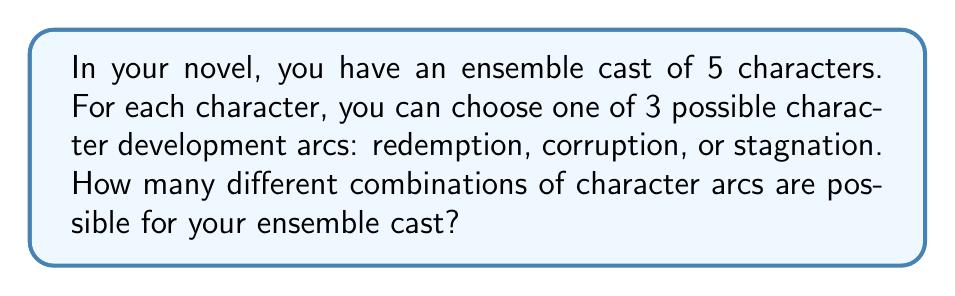Could you help me with this problem? Let's approach this step-by-step:

1) We have 5 characters, and for each character, we have 3 choices of character arcs.

2) This scenario is a perfect example of the multiplication principle in combinatorics. When we have a series of independent choices, we multiply the number of options for each choice.

3) In this case, we're making 5 independent choices (one for each character), and each choice has 3 options.

4) Therefore, the total number of possible combinations is:

   $$3 \times 3 \times 3 \times 3 \times 3 = 3^5$$

5) We can calculate this:

   $$3^5 = 3 \times 3 \times 3 \times 3 \times 3 = 243$$

6) This means there are 243 different ways to assign character arcs to your ensemble cast.

This large number of possibilities demonstrates the vast creative potential in character development, which might help overcome writer's block by exploring the numerous narrative directions available.
Answer: $3^5 = 243$ 